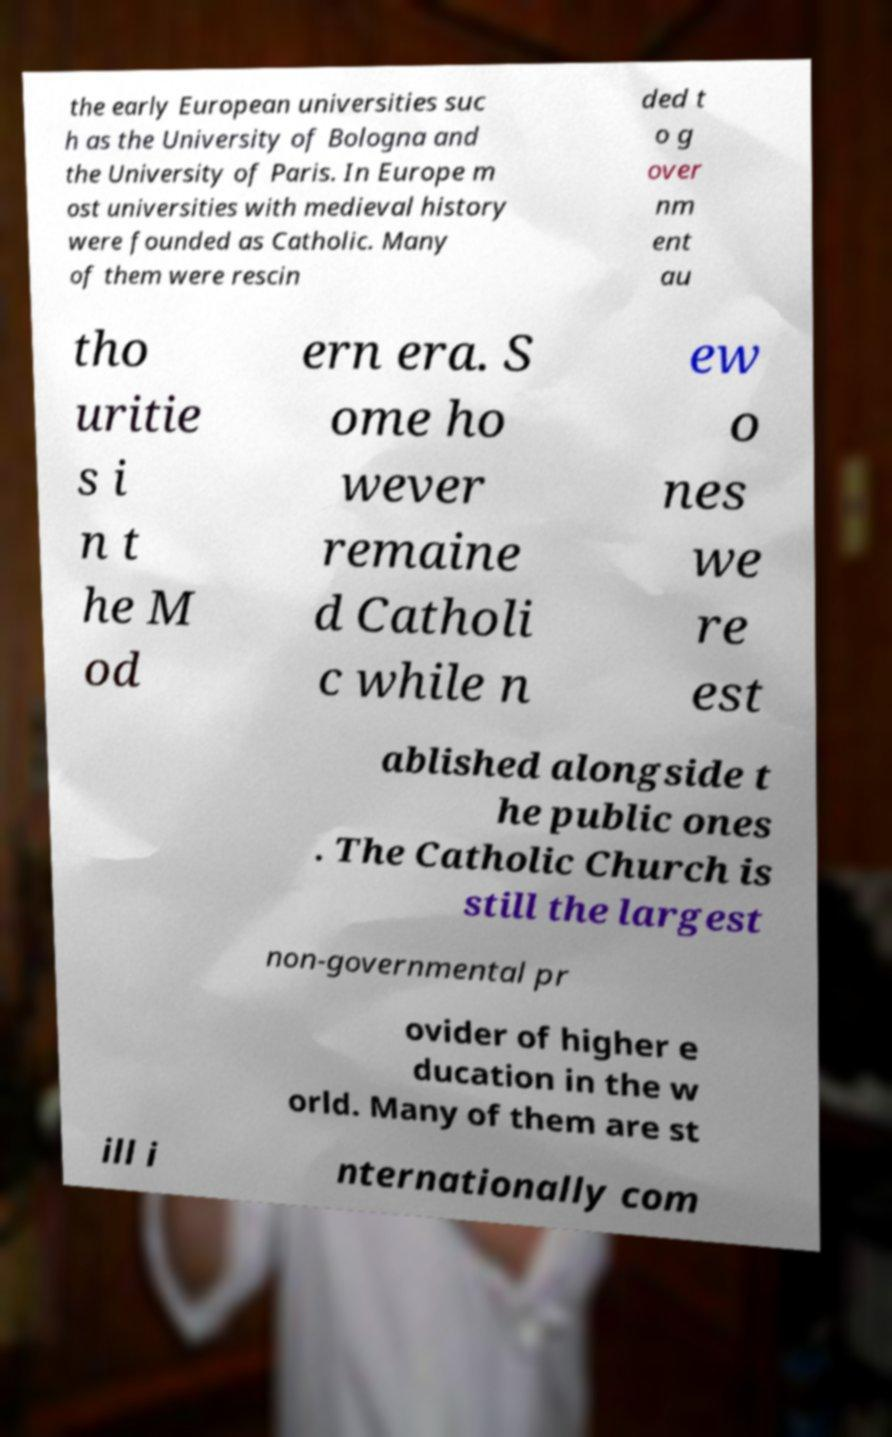There's text embedded in this image that I need extracted. Can you transcribe it verbatim? the early European universities suc h as the University of Bologna and the University of Paris. In Europe m ost universities with medieval history were founded as Catholic. Many of them were rescin ded t o g over nm ent au tho uritie s i n t he M od ern era. S ome ho wever remaine d Catholi c while n ew o nes we re est ablished alongside t he public ones . The Catholic Church is still the largest non-governmental pr ovider of higher e ducation in the w orld. Many of them are st ill i nternationally com 